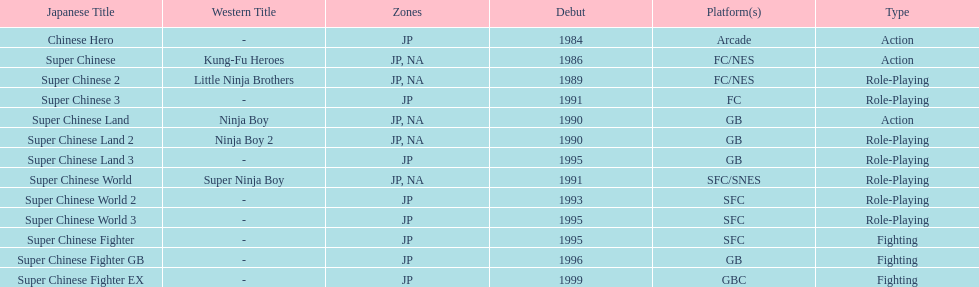When was the last super chinese game released? 1999. 